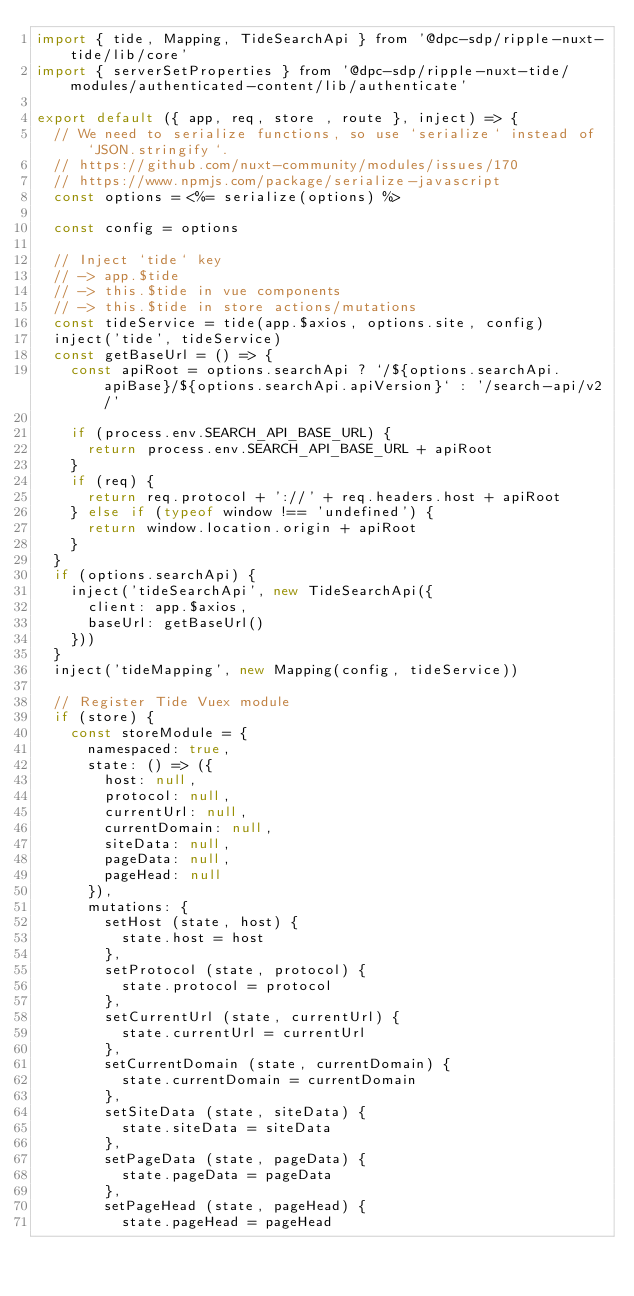Convert code to text. <code><loc_0><loc_0><loc_500><loc_500><_JavaScript_>import { tide, Mapping, TideSearchApi } from '@dpc-sdp/ripple-nuxt-tide/lib/core'
import { serverSetProperties } from '@dpc-sdp/ripple-nuxt-tide/modules/authenticated-content/lib/authenticate'

export default ({ app, req, store , route }, inject) => {
  // We need to serialize functions, so use `serialize` instead of `JSON.stringify`.
  // https://github.com/nuxt-community/modules/issues/170
  // https://www.npmjs.com/package/serialize-javascript
  const options = <%= serialize(options) %>

  const config = options

  // Inject `tide` key
  // -> app.$tide
  // -> this.$tide in vue components
  // -> this.$tide in store actions/mutations
  const tideService = tide(app.$axios, options.site, config)
  inject('tide', tideService)
  const getBaseUrl = () => {
    const apiRoot = options.searchApi ? `/${options.searchApi.apiBase}/${options.searchApi.apiVersion}` : '/search-api/v2/'

    if (process.env.SEARCH_API_BASE_URL) {
      return process.env.SEARCH_API_BASE_URL + apiRoot
    }
    if (req) {
      return req.protocol + '://' + req.headers.host + apiRoot
    } else if (typeof window !== 'undefined') {
      return window.location.origin + apiRoot
    }
  }
  if (options.searchApi) {
    inject('tideSearchApi', new TideSearchApi({
      client: app.$axios,
      baseUrl: getBaseUrl()
    }))
  }
  inject('tideMapping', new Mapping(config, tideService))

  // Register Tide Vuex module
  if (store) {
    const storeModule = {
      namespaced: true,
      state: () => ({
        host: null,
        protocol: null,
        currentUrl: null,
        currentDomain: null,
        siteData: null,
        pageData: null,
        pageHead: null
      }),
      mutations: {
        setHost (state, host) {
          state.host = host
        },
        setProtocol (state, protocol) {
          state.protocol = protocol
        },
        setCurrentUrl (state, currentUrl) {
          state.currentUrl = currentUrl
        },
        setCurrentDomain (state, currentDomain) {
          state.currentDomain = currentDomain
        },
        setSiteData (state, siteData) {
          state.siteData = siteData
        },
        setPageData (state, pageData) {
          state.pageData = pageData
        },
        setPageHead (state, pageHead) {
          state.pageHead = pageHead</code> 